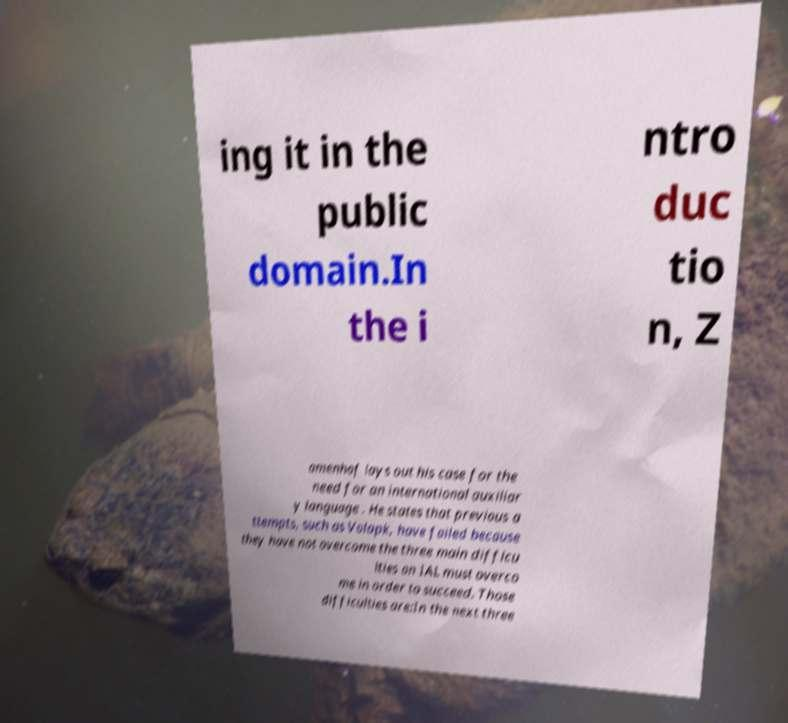Can you accurately transcribe the text from the provided image for me? ing it in the public domain.In the i ntro duc tio n, Z amenhof lays out his case for the need for an international auxiliar y language . He states that previous a ttempts, such as Volapk, have failed because they have not overcome the three main difficu lties an IAL must overco me in order to succeed. Those difficulties are:In the next three 